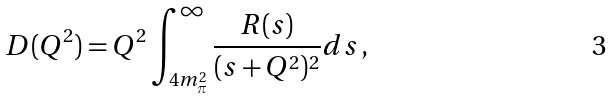<formula> <loc_0><loc_0><loc_500><loc_500>D ( Q ^ { 2 } ) = Q ^ { 2 } \int _ { 4 m _ { \pi } ^ { 2 } } ^ { \infty } \frac { R ( s ) } { ( s + Q ^ { 2 } ) ^ { 2 } } d s \, ,</formula> 